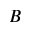<formula> <loc_0><loc_0><loc_500><loc_500>B</formula> 